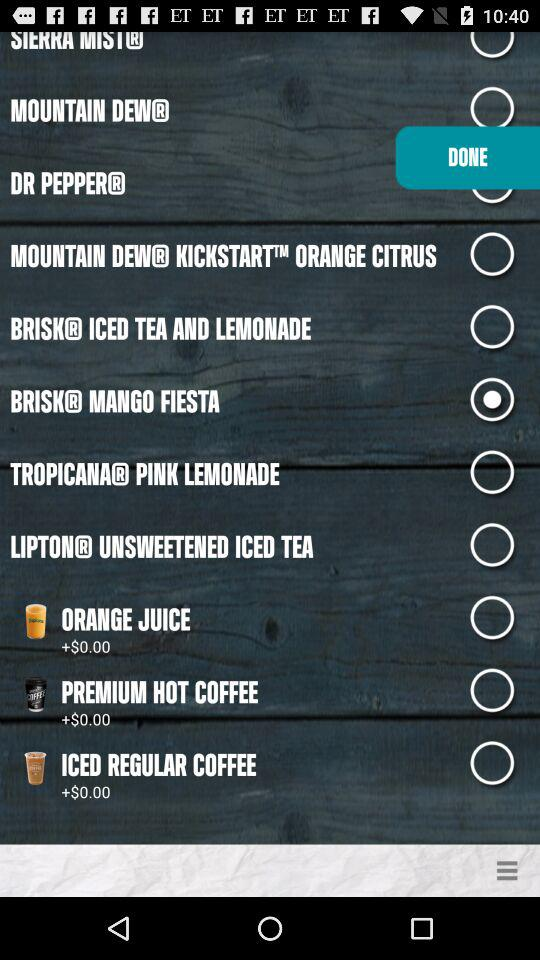What is the price of iced regular coffee? The price is $0.00. 